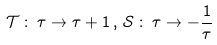<formula> <loc_0><loc_0><loc_500><loc_500>\mathcal { T } \, \colon \, \tau \rightarrow \tau + 1 \, , \, \mathcal { S } \, \colon \, \tau \rightarrow - \frac { 1 } { \tau }</formula> 